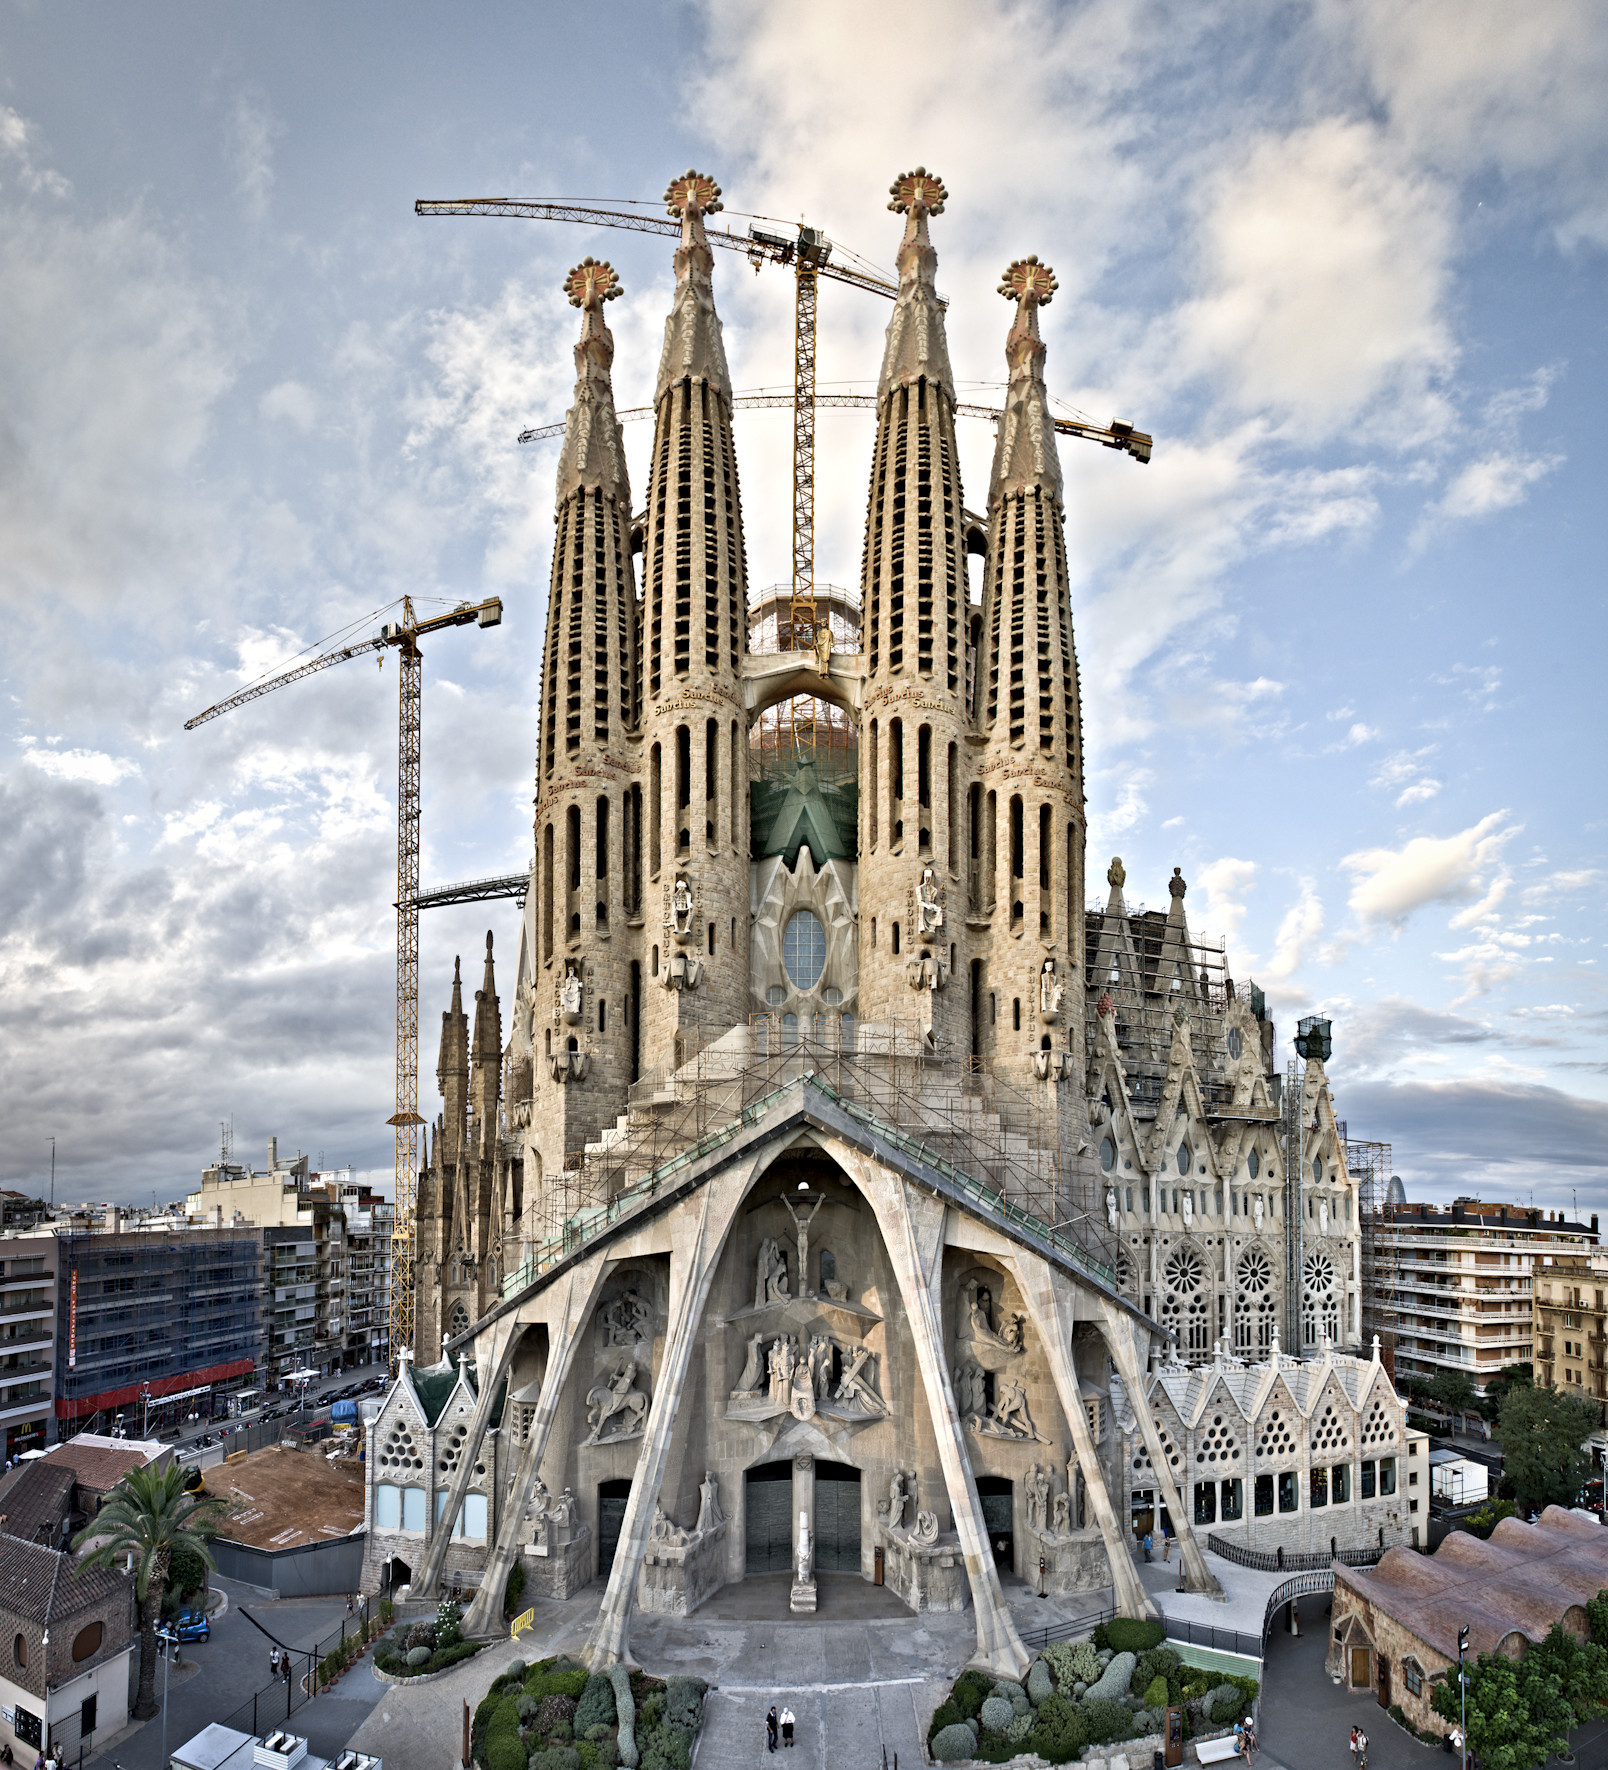If this image were turned into a painting, what style do you think would best capture its essence? If this image were to be transformed into a painting, the Gothic Revival style would best capture its essence. This style, characterized by intricate details, soaring vertical lines, and dramatic contrasts, would reflect the architectural splendor of the Sagrada Familia. The artist might use deep, rich colors to highlight the church’s detailed carvings and sculptures, while softer tones would depict the surrounding urban landscape in harmony with the sky.

Another fitting style could be Catalan Modernisme, which would pay homage to Gaudí’s own artistic influences. This approach could incorporate flowing, organic forms and vibrant mosaics to bring the scene to life, emphasizing the dynamic interplay between nature and architecture that Gaudí championed. 